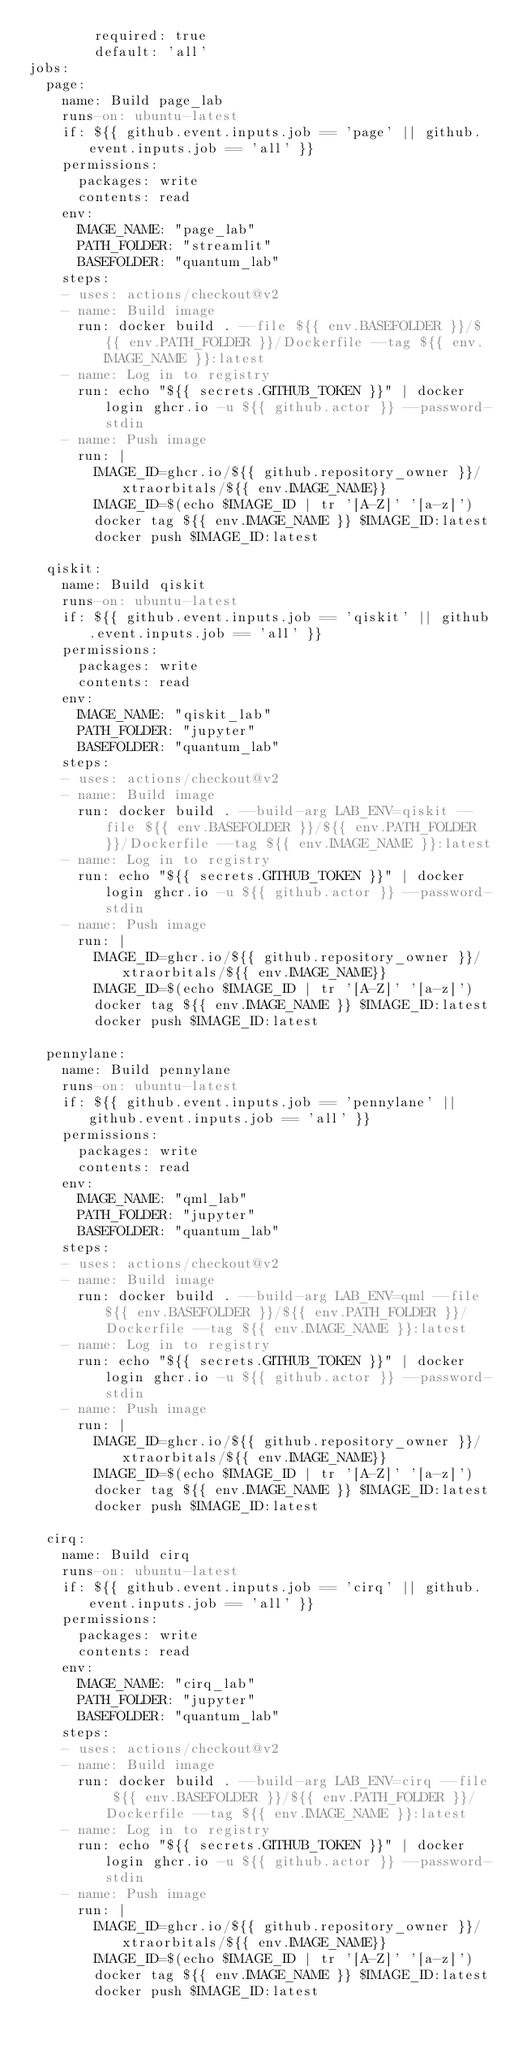Convert code to text. <code><loc_0><loc_0><loc_500><loc_500><_YAML_>        required: true
        default: 'all'
jobs:
  page:
    name: Build page_lab
    runs-on: ubuntu-latest
    if: ${{ github.event.inputs.job == 'page' || github.event.inputs.job == 'all' }}
    permissions:
      packages: write
      contents: read
    env:
      IMAGE_NAME: "page_lab"
      PATH_FOLDER: "streamlit"
      BASEFOLDER: "quantum_lab"
    steps:
    - uses: actions/checkout@v2
    - name: Build image
      run: docker build . --file ${{ env.BASEFOLDER }}/${{ env.PATH_FOLDER }}/Dockerfile --tag ${{ env.IMAGE_NAME }}:latest
    - name: Log in to registry
      run: echo "${{ secrets.GITHUB_TOKEN }}" | docker login ghcr.io -u ${{ github.actor }} --password-stdin
    - name: Push image
      run: |
        IMAGE_ID=ghcr.io/${{ github.repository_owner }}/xtraorbitals/${{ env.IMAGE_NAME}}
        IMAGE_ID=$(echo $IMAGE_ID | tr '[A-Z]' '[a-z]')
        docker tag ${{ env.IMAGE_NAME }} $IMAGE_ID:latest
        docker push $IMAGE_ID:latest
        
  qiskit:
    name: Build qiskit
    runs-on: ubuntu-latest
    if: ${{ github.event.inputs.job == 'qiskit' || github.event.inputs.job == 'all' }}
    permissions:
      packages: write
      contents: read
    env:
      IMAGE_NAME: "qiskit_lab"
      PATH_FOLDER: "jupyter"
      BASEFOLDER: "quantum_lab"
    steps:
    - uses: actions/checkout@v2
    - name: Build image
      run: docker build . --build-arg LAB_ENV=qiskit --file ${{ env.BASEFOLDER }}/${{ env.PATH_FOLDER }}/Dockerfile --tag ${{ env.IMAGE_NAME }}:latest
    - name: Log in to registry
      run: echo "${{ secrets.GITHUB_TOKEN }}" | docker login ghcr.io -u ${{ github.actor }} --password-stdin
    - name: Push image
      run: |
        IMAGE_ID=ghcr.io/${{ github.repository_owner }}/xtraorbitals/${{ env.IMAGE_NAME}}
        IMAGE_ID=$(echo $IMAGE_ID | tr '[A-Z]' '[a-z]')
        docker tag ${{ env.IMAGE_NAME }} $IMAGE_ID:latest
        docker push $IMAGE_ID:latest
        
  pennylane:
    name: Build pennylane
    runs-on: ubuntu-latest
    if: ${{ github.event.inputs.job == 'pennylane' || github.event.inputs.job == 'all' }}
    permissions:
      packages: write
      contents: read
    env:
      IMAGE_NAME: "qml_lab"
      PATH_FOLDER: "jupyter"
      BASEFOLDER: "quantum_lab"
    steps:
    - uses: actions/checkout@v2
    - name: Build image
      run: docker build . --build-arg LAB_ENV=qml --file ${{ env.BASEFOLDER }}/${{ env.PATH_FOLDER }}/Dockerfile --tag ${{ env.IMAGE_NAME }}:latest
    - name: Log in to registry
      run: echo "${{ secrets.GITHUB_TOKEN }}" | docker login ghcr.io -u ${{ github.actor }} --password-stdin
    - name: Push image
      run: |
        IMAGE_ID=ghcr.io/${{ github.repository_owner }}/xtraorbitals/${{ env.IMAGE_NAME}}
        IMAGE_ID=$(echo $IMAGE_ID | tr '[A-Z]' '[a-z]')
        docker tag ${{ env.IMAGE_NAME }} $IMAGE_ID:latest
        docker push $IMAGE_ID:latest
        
  cirq:
    name: Build cirq
    runs-on: ubuntu-latest
    if: ${{ github.event.inputs.job == 'cirq' || github.event.inputs.job == 'all' }}
    permissions:
      packages: write
      contents: read
    env:
      IMAGE_NAME: "cirq_lab"
      PATH_FOLDER: "jupyter"
      BASEFOLDER: "quantum_lab"
    steps:
    - uses: actions/checkout@v2
    - name: Build image
      run: docker build . --build-arg LAB_ENV=cirq --file ${{ env.BASEFOLDER }}/${{ env.PATH_FOLDER }}/Dockerfile --tag ${{ env.IMAGE_NAME }}:latest
    - name: Log in to registry
      run: echo "${{ secrets.GITHUB_TOKEN }}" | docker login ghcr.io -u ${{ github.actor }} --password-stdin
    - name: Push image
      run: |
        IMAGE_ID=ghcr.io/${{ github.repository_owner }}/xtraorbitals/${{ env.IMAGE_NAME}}
        IMAGE_ID=$(echo $IMAGE_ID | tr '[A-Z]' '[a-z]')
        docker tag ${{ env.IMAGE_NAME }} $IMAGE_ID:latest
        docker push $IMAGE_ID:latest
</code> 